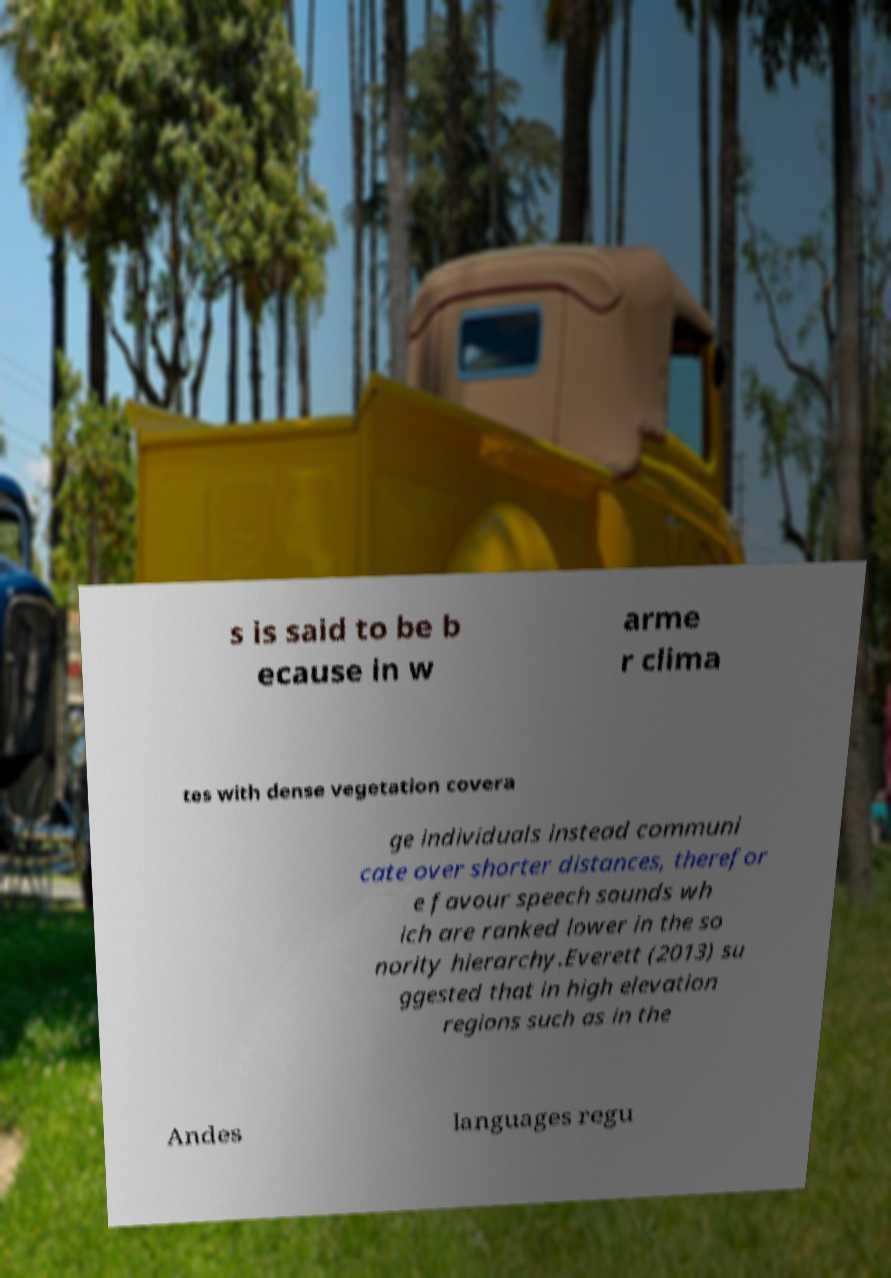Please read and relay the text visible in this image. What does it say? s is said to be b ecause in w arme r clima tes with dense vegetation covera ge individuals instead communi cate over shorter distances, therefor e favour speech sounds wh ich are ranked lower in the so nority hierarchy.Everett (2013) su ggested that in high elevation regions such as in the Andes languages regu 